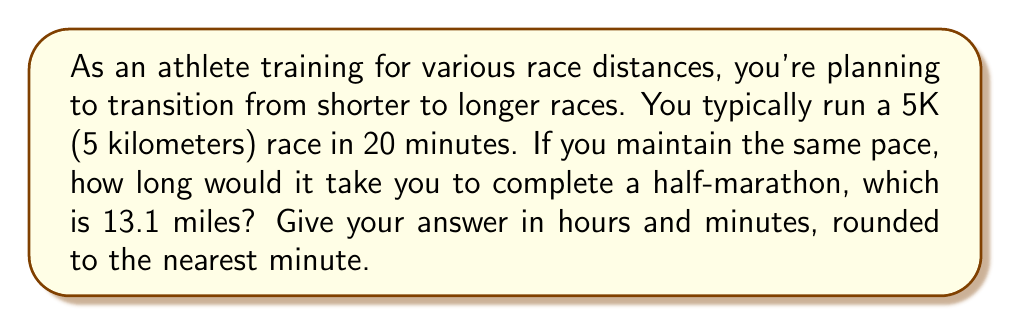Provide a solution to this math problem. To solve this problem, we need to follow these steps:

1. Convert the half-marathon distance from miles to kilometers:
   13.1 miles = 13.1 × 1.60934 km = 21.0824 km

2. Calculate the pace in km/min from the 5K race:
   Pace = 5 km ÷ 20 min = 0.25 km/min

3. Calculate the time for the half-marathon:
   Time = Distance ÷ Pace
   Time = 21.0824 km ÷ 0.25 km/min = 84.3296 min

4. Convert the time to hours and minutes:
   84.3296 min = 1 hour and 24.3296 min

5. Round to the nearest minute:
   1 hour and 24 minutes

Let's express this mathematically:

$$\text{Half-marathon distance} = 13.1 \times 1.60934 = 21.0824 \text{ km}$$
$$\text{Pace} = \frac{5 \text{ km}}{20 \text{ min}} = 0.25 \text{ km/min}$$
$$\text{Time} = \frac{21.0824 \text{ km}}{0.25 \text{ km/min}} = 84.3296 \text{ min}$$
$$84.3296 \text{ min} = 1 \text{ hour} + 24.3296 \text{ min} \approx 1 \text{ hour} + 24 \text{ min}$$
Answer: 1 hour and 24 minutes 